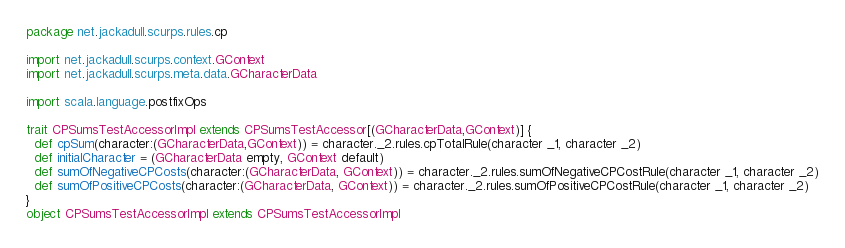Convert code to text. <code><loc_0><loc_0><loc_500><loc_500><_Scala_>package net.jackadull.scurps.rules.cp

import net.jackadull.scurps.context.GContext
import net.jackadull.scurps.meta.data.GCharacterData

import scala.language.postfixOps

trait CPSumsTestAccessorImpl extends CPSumsTestAccessor[(GCharacterData,GContext)] {
  def cpSum(character:(GCharacterData,GContext)) = character._2.rules.cpTotalRule(character _1, character _2)
  def initialCharacter = (GCharacterData empty, GContext default)
  def sumOfNegativeCPCosts(character:(GCharacterData, GContext)) = character._2.rules.sumOfNegativeCPCostRule(character _1, character _2)
  def sumOfPositiveCPCosts(character:(GCharacterData, GContext)) = character._2.rules.sumOfPositiveCPCostRule(character _1, character _2)
}
object CPSumsTestAccessorImpl extends CPSumsTestAccessorImpl
</code> 